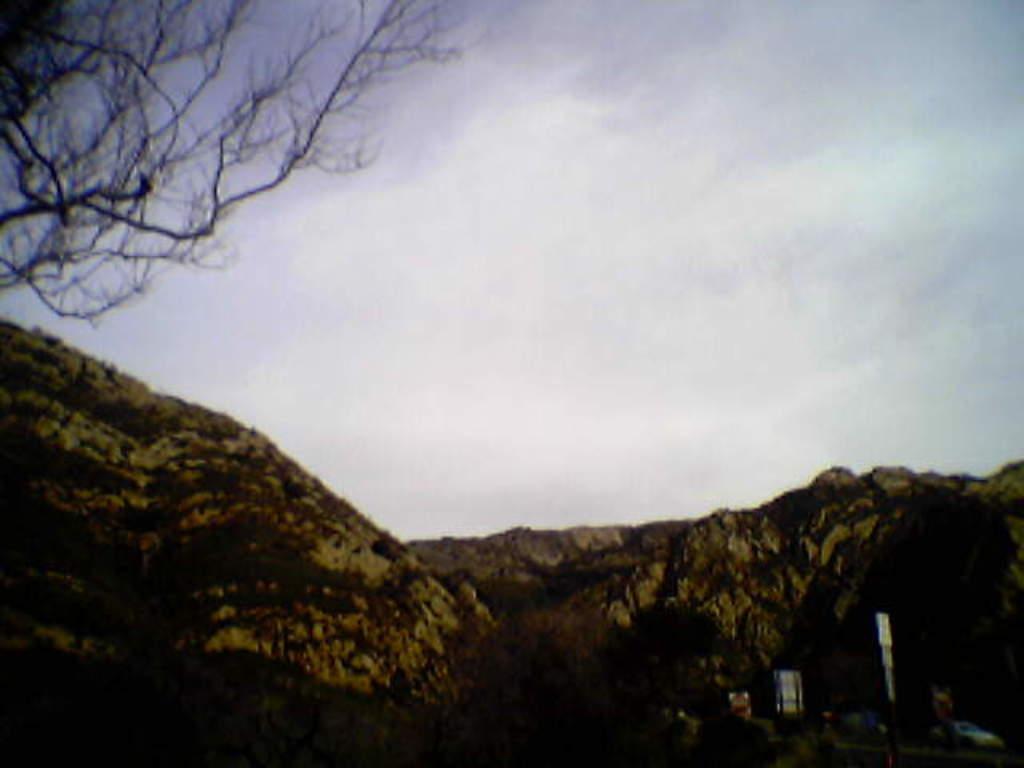How would you summarize this image in a sentence or two? In the center of the image there are hills. On the left we can see a tree. In the background there is sky. 